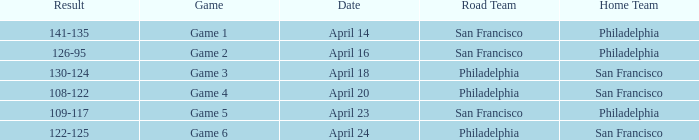On what date was game 2 played? April 16. 